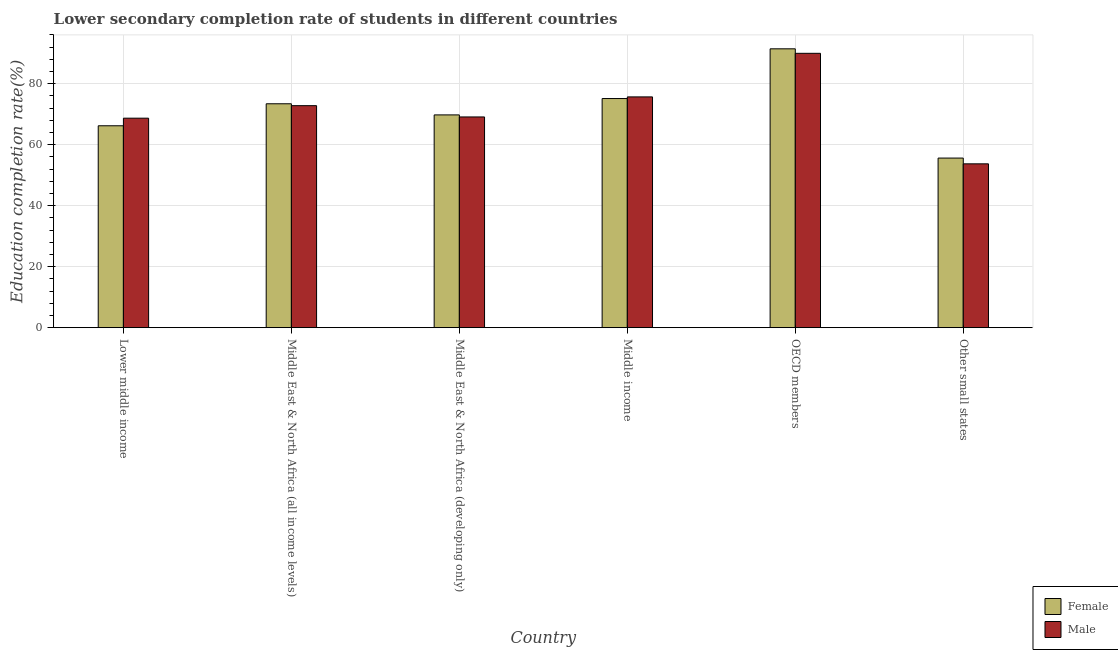How many different coloured bars are there?
Offer a very short reply. 2. What is the label of the 3rd group of bars from the left?
Give a very brief answer. Middle East & North Africa (developing only). What is the education completion rate of male students in Middle East & North Africa (all income levels)?
Offer a terse response. 72.82. Across all countries, what is the maximum education completion rate of female students?
Make the answer very short. 91.46. Across all countries, what is the minimum education completion rate of female students?
Keep it short and to the point. 55.63. In which country was the education completion rate of male students minimum?
Make the answer very short. Other small states. What is the total education completion rate of male students in the graph?
Keep it short and to the point. 430.06. What is the difference between the education completion rate of male students in Lower middle income and that in Other small states?
Your answer should be compact. 14.98. What is the difference between the education completion rate of male students in Middle East & North Africa (developing only) and the education completion rate of female students in Middle East & North Africa (all income levels)?
Your answer should be compact. -4.32. What is the average education completion rate of female students per country?
Ensure brevity in your answer.  71.95. What is the difference between the education completion rate of female students and education completion rate of male students in OECD members?
Give a very brief answer. 1.48. In how many countries, is the education completion rate of female students greater than 8 %?
Provide a short and direct response. 6. What is the ratio of the education completion rate of female students in Middle East & North Africa (all income levels) to that in Middle income?
Offer a very short reply. 0.98. Is the education completion rate of female students in Middle East & North Africa (all income levels) less than that in Middle income?
Provide a short and direct response. Yes. What is the difference between the highest and the second highest education completion rate of male students?
Your response must be concise. 14.29. What is the difference between the highest and the lowest education completion rate of female students?
Your response must be concise. 35.84. In how many countries, is the education completion rate of male students greater than the average education completion rate of male students taken over all countries?
Your answer should be very brief. 3. What does the 1st bar from the right in Other small states represents?
Offer a very short reply. Male. How many bars are there?
Offer a very short reply. 12. Are all the bars in the graph horizontal?
Offer a terse response. No. How many countries are there in the graph?
Provide a succinct answer. 6. Are the values on the major ticks of Y-axis written in scientific E-notation?
Keep it short and to the point. No. Does the graph contain any zero values?
Provide a succinct answer. No. Where does the legend appear in the graph?
Offer a terse response. Bottom right. How many legend labels are there?
Your response must be concise. 2. How are the legend labels stacked?
Your answer should be very brief. Vertical. What is the title of the graph?
Give a very brief answer. Lower secondary completion rate of students in different countries. Does "Mobile cellular" appear as one of the legend labels in the graph?
Your response must be concise. No. What is the label or title of the X-axis?
Offer a very short reply. Country. What is the label or title of the Y-axis?
Offer a very short reply. Education completion rate(%). What is the Education completion rate(%) of Female in Lower middle income?
Keep it short and to the point. 66.22. What is the Education completion rate(%) in Male in Lower middle income?
Ensure brevity in your answer.  68.71. What is the Education completion rate(%) of Female in Middle East & North Africa (all income levels)?
Provide a short and direct response. 73.44. What is the Education completion rate(%) in Male in Middle East & North Africa (all income levels)?
Provide a short and direct response. 72.82. What is the Education completion rate(%) in Female in Middle East & North Africa (developing only)?
Keep it short and to the point. 69.78. What is the Education completion rate(%) in Male in Middle East & North Africa (developing only)?
Your answer should be compact. 69.12. What is the Education completion rate(%) in Female in Middle income?
Make the answer very short. 75.15. What is the Education completion rate(%) of Male in Middle income?
Make the answer very short. 75.69. What is the Education completion rate(%) in Female in OECD members?
Offer a terse response. 91.46. What is the Education completion rate(%) in Male in OECD members?
Provide a succinct answer. 89.99. What is the Education completion rate(%) of Female in Other small states?
Offer a terse response. 55.63. What is the Education completion rate(%) of Male in Other small states?
Make the answer very short. 53.74. Across all countries, what is the maximum Education completion rate(%) in Female?
Provide a short and direct response. 91.46. Across all countries, what is the maximum Education completion rate(%) of Male?
Offer a very short reply. 89.99. Across all countries, what is the minimum Education completion rate(%) in Female?
Ensure brevity in your answer.  55.63. Across all countries, what is the minimum Education completion rate(%) in Male?
Your response must be concise. 53.74. What is the total Education completion rate(%) in Female in the graph?
Your response must be concise. 431.69. What is the total Education completion rate(%) of Male in the graph?
Provide a short and direct response. 430.06. What is the difference between the Education completion rate(%) of Female in Lower middle income and that in Middle East & North Africa (all income levels)?
Offer a terse response. -7.21. What is the difference between the Education completion rate(%) of Male in Lower middle income and that in Middle East & North Africa (all income levels)?
Your response must be concise. -4.1. What is the difference between the Education completion rate(%) of Female in Lower middle income and that in Middle East & North Africa (developing only)?
Your response must be concise. -3.56. What is the difference between the Education completion rate(%) of Male in Lower middle income and that in Middle East & North Africa (developing only)?
Your answer should be very brief. -0.4. What is the difference between the Education completion rate(%) of Female in Lower middle income and that in Middle income?
Ensure brevity in your answer.  -8.93. What is the difference between the Education completion rate(%) in Male in Lower middle income and that in Middle income?
Your response must be concise. -6.98. What is the difference between the Education completion rate(%) in Female in Lower middle income and that in OECD members?
Give a very brief answer. -25.24. What is the difference between the Education completion rate(%) of Male in Lower middle income and that in OECD members?
Your answer should be compact. -21.27. What is the difference between the Education completion rate(%) in Female in Lower middle income and that in Other small states?
Your answer should be very brief. 10.6. What is the difference between the Education completion rate(%) of Male in Lower middle income and that in Other small states?
Your answer should be very brief. 14.98. What is the difference between the Education completion rate(%) in Female in Middle East & North Africa (all income levels) and that in Middle East & North Africa (developing only)?
Offer a terse response. 3.65. What is the difference between the Education completion rate(%) of Male in Middle East & North Africa (all income levels) and that in Middle East & North Africa (developing only)?
Give a very brief answer. 3.7. What is the difference between the Education completion rate(%) of Female in Middle East & North Africa (all income levels) and that in Middle income?
Ensure brevity in your answer.  -1.72. What is the difference between the Education completion rate(%) of Male in Middle East & North Africa (all income levels) and that in Middle income?
Ensure brevity in your answer.  -2.87. What is the difference between the Education completion rate(%) of Female in Middle East & North Africa (all income levels) and that in OECD members?
Your response must be concise. -18.03. What is the difference between the Education completion rate(%) in Male in Middle East & North Africa (all income levels) and that in OECD members?
Provide a succinct answer. -17.17. What is the difference between the Education completion rate(%) of Female in Middle East & North Africa (all income levels) and that in Other small states?
Ensure brevity in your answer.  17.81. What is the difference between the Education completion rate(%) in Male in Middle East & North Africa (all income levels) and that in Other small states?
Keep it short and to the point. 19.08. What is the difference between the Education completion rate(%) of Female in Middle East & North Africa (developing only) and that in Middle income?
Make the answer very short. -5.37. What is the difference between the Education completion rate(%) in Male in Middle East & North Africa (developing only) and that in Middle income?
Offer a terse response. -6.57. What is the difference between the Education completion rate(%) of Female in Middle East & North Africa (developing only) and that in OECD members?
Your answer should be very brief. -21.68. What is the difference between the Education completion rate(%) in Male in Middle East & North Africa (developing only) and that in OECD members?
Your response must be concise. -20.87. What is the difference between the Education completion rate(%) in Female in Middle East & North Africa (developing only) and that in Other small states?
Keep it short and to the point. 14.16. What is the difference between the Education completion rate(%) of Male in Middle East & North Africa (developing only) and that in Other small states?
Your answer should be compact. 15.38. What is the difference between the Education completion rate(%) in Female in Middle income and that in OECD members?
Your answer should be very brief. -16.31. What is the difference between the Education completion rate(%) in Male in Middle income and that in OECD members?
Give a very brief answer. -14.29. What is the difference between the Education completion rate(%) of Female in Middle income and that in Other small states?
Ensure brevity in your answer.  19.53. What is the difference between the Education completion rate(%) of Male in Middle income and that in Other small states?
Provide a short and direct response. 21.96. What is the difference between the Education completion rate(%) in Female in OECD members and that in Other small states?
Ensure brevity in your answer.  35.84. What is the difference between the Education completion rate(%) of Male in OECD members and that in Other small states?
Your response must be concise. 36.25. What is the difference between the Education completion rate(%) in Female in Lower middle income and the Education completion rate(%) in Male in Middle East & North Africa (all income levels)?
Keep it short and to the point. -6.6. What is the difference between the Education completion rate(%) in Female in Lower middle income and the Education completion rate(%) in Male in Middle East & North Africa (developing only)?
Ensure brevity in your answer.  -2.89. What is the difference between the Education completion rate(%) of Female in Lower middle income and the Education completion rate(%) of Male in Middle income?
Your answer should be compact. -9.47. What is the difference between the Education completion rate(%) of Female in Lower middle income and the Education completion rate(%) of Male in OECD members?
Your response must be concise. -23.76. What is the difference between the Education completion rate(%) in Female in Lower middle income and the Education completion rate(%) in Male in Other small states?
Ensure brevity in your answer.  12.49. What is the difference between the Education completion rate(%) of Female in Middle East & North Africa (all income levels) and the Education completion rate(%) of Male in Middle East & North Africa (developing only)?
Make the answer very short. 4.32. What is the difference between the Education completion rate(%) of Female in Middle East & North Africa (all income levels) and the Education completion rate(%) of Male in Middle income?
Your answer should be very brief. -2.26. What is the difference between the Education completion rate(%) in Female in Middle East & North Africa (all income levels) and the Education completion rate(%) in Male in OECD members?
Your answer should be very brief. -16.55. What is the difference between the Education completion rate(%) in Female in Middle East & North Africa (all income levels) and the Education completion rate(%) in Male in Other small states?
Provide a short and direct response. 19.7. What is the difference between the Education completion rate(%) of Female in Middle East & North Africa (developing only) and the Education completion rate(%) of Male in Middle income?
Ensure brevity in your answer.  -5.91. What is the difference between the Education completion rate(%) in Female in Middle East & North Africa (developing only) and the Education completion rate(%) in Male in OECD members?
Offer a terse response. -20.2. What is the difference between the Education completion rate(%) in Female in Middle East & North Africa (developing only) and the Education completion rate(%) in Male in Other small states?
Your answer should be compact. 16.05. What is the difference between the Education completion rate(%) of Female in Middle income and the Education completion rate(%) of Male in OECD members?
Your answer should be very brief. -14.83. What is the difference between the Education completion rate(%) in Female in Middle income and the Education completion rate(%) in Male in Other small states?
Your answer should be compact. 21.42. What is the difference between the Education completion rate(%) of Female in OECD members and the Education completion rate(%) of Male in Other small states?
Make the answer very short. 37.73. What is the average Education completion rate(%) of Female per country?
Ensure brevity in your answer.  71.95. What is the average Education completion rate(%) in Male per country?
Provide a short and direct response. 71.68. What is the difference between the Education completion rate(%) of Female and Education completion rate(%) of Male in Lower middle income?
Your answer should be very brief. -2.49. What is the difference between the Education completion rate(%) of Female and Education completion rate(%) of Male in Middle East & North Africa (all income levels)?
Give a very brief answer. 0.62. What is the difference between the Education completion rate(%) of Female and Education completion rate(%) of Male in Middle East & North Africa (developing only)?
Your response must be concise. 0.67. What is the difference between the Education completion rate(%) in Female and Education completion rate(%) in Male in Middle income?
Offer a very short reply. -0.54. What is the difference between the Education completion rate(%) of Female and Education completion rate(%) of Male in OECD members?
Keep it short and to the point. 1.48. What is the difference between the Education completion rate(%) in Female and Education completion rate(%) in Male in Other small states?
Ensure brevity in your answer.  1.89. What is the ratio of the Education completion rate(%) of Female in Lower middle income to that in Middle East & North Africa (all income levels)?
Offer a very short reply. 0.9. What is the ratio of the Education completion rate(%) of Male in Lower middle income to that in Middle East & North Africa (all income levels)?
Your response must be concise. 0.94. What is the ratio of the Education completion rate(%) of Female in Lower middle income to that in Middle East & North Africa (developing only)?
Offer a terse response. 0.95. What is the ratio of the Education completion rate(%) in Female in Lower middle income to that in Middle income?
Make the answer very short. 0.88. What is the ratio of the Education completion rate(%) of Male in Lower middle income to that in Middle income?
Give a very brief answer. 0.91. What is the ratio of the Education completion rate(%) of Female in Lower middle income to that in OECD members?
Your answer should be compact. 0.72. What is the ratio of the Education completion rate(%) of Male in Lower middle income to that in OECD members?
Your answer should be compact. 0.76. What is the ratio of the Education completion rate(%) of Female in Lower middle income to that in Other small states?
Provide a succinct answer. 1.19. What is the ratio of the Education completion rate(%) of Male in Lower middle income to that in Other small states?
Your answer should be compact. 1.28. What is the ratio of the Education completion rate(%) of Female in Middle East & North Africa (all income levels) to that in Middle East & North Africa (developing only)?
Ensure brevity in your answer.  1.05. What is the ratio of the Education completion rate(%) in Male in Middle East & North Africa (all income levels) to that in Middle East & North Africa (developing only)?
Keep it short and to the point. 1.05. What is the ratio of the Education completion rate(%) in Female in Middle East & North Africa (all income levels) to that in Middle income?
Provide a short and direct response. 0.98. What is the ratio of the Education completion rate(%) of Male in Middle East & North Africa (all income levels) to that in Middle income?
Offer a terse response. 0.96. What is the ratio of the Education completion rate(%) in Female in Middle East & North Africa (all income levels) to that in OECD members?
Your answer should be compact. 0.8. What is the ratio of the Education completion rate(%) in Male in Middle East & North Africa (all income levels) to that in OECD members?
Your answer should be very brief. 0.81. What is the ratio of the Education completion rate(%) in Female in Middle East & North Africa (all income levels) to that in Other small states?
Provide a succinct answer. 1.32. What is the ratio of the Education completion rate(%) in Male in Middle East & North Africa (all income levels) to that in Other small states?
Give a very brief answer. 1.36. What is the ratio of the Education completion rate(%) of Male in Middle East & North Africa (developing only) to that in Middle income?
Offer a terse response. 0.91. What is the ratio of the Education completion rate(%) in Female in Middle East & North Africa (developing only) to that in OECD members?
Give a very brief answer. 0.76. What is the ratio of the Education completion rate(%) of Male in Middle East & North Africa (developing only) to that in OECD members?
Offer a terse response. 0.77. What is the ratio of the Education completion rate(%) of Female in Middle East & North Africa (developing only) to that in Other small states?
Keep it short and to the point. 1.25. What is the ratio of the Education completion rate(%) in Male in Middle East & North Africa (developing only) to that in Other small states?
Your answer should be compact. 1.29. What is the ratio of the Education completion rate(%) in Female in Middle income to that in OECD members?
Provide a succinct answer. 0.82. What is the ratio of the Education completion rate(%) in Male in Middle income to that in OECD members?
Your answer should be compact. 0.84. What is the ratio of the Education completion rate(%) of Female in Middle income to that in Other small states?
Your answer should be compact. 1.35. What is the ratio of the Education completion rate(%) in Male in Middle income to that in Other small states?
Your answer should be compact. 1.41. What is the ratio of the Education completion rate(%) of Female in OECD members to that in Other small states?
Offer a very short reply. 1.64. What is the ratio of the Education completion rate(%) of Male in OECD members to that in Other small states?
Your response must be concise. 1.67. What is the difference between the highest and the second highest Education completion rate(%) of Female?
Make the answer very short. 16.31. What is the difference between the highest and the second highest Education completion rate(%) of Male?
Provide a short and direct response. 14.29. What is the difference between the highest and the lowest Education completion rate(%) of Female?
Your response must be concise. 35.84. What is the difference between the highest and the lowest Education completion rate(%) in Male?
Provide a succinct answer. 36.25. 